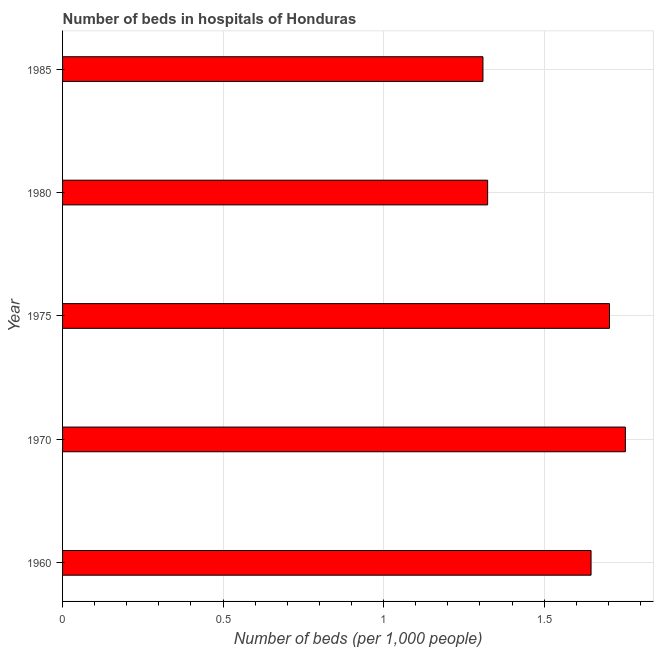Does the graph contain grids?
Offer a very short reply. Yes. What is the title of the graph?
Ensure brevity in your answer.  Number of beds in hospitals of Honduras. What is the label or title of the X-axis?
Give a very brief answer. Number of beds (per 1,0 people). What is the number of hospital beds in 1975?
Offer a very short reply. 1.7. Across all years, what is the maximum number of hospital beds?
Ensure brevity in your answer.  1.75. Across all years, what is the minimum number of hospital beds?
Offer a terse response. 1.31. In which year was the number of hospital beds maximum?
Offer a terse response. 1970. In which year was the number of hospital beds minimum?
Provide a short and direct response. 1985. What is the sum of the number of hospital beds?
Ensure brevity in your answer.  7.74. What is the difference between the number of hospital beds in 1975 and 1980?
Your answer should be very brief. 0.38. What is the average number of hospital beds per year?
Offer a very short reply. 1.55. What is the median number of hospital beds?
Provide a succinct answer. 1.65. Do a majority of the years between 1985 and 1970 (inclusive) have number of hospital beds greater than 1.2 %?
Make the answer very short. Yes. What is the ratio of the number of hospital beds in 1975 to that in 1985?
Make the answer very short. 1.3. Is the number of hospital beds in 1970 less than that in 1975?
Make the answer very short. No. Is the difference between the number of hospital beds in 1970 and 1975 greater than the difference between any two years?
Make the answer very short. No. What is the difference between the highest and the second highest number of hospital beds?
Your answer should be compact. 0.05. What is the difference between the highest and the lowest number of hospital beds?
Provide a short and direct response. 0.44. In how many years, is the number of hospital beds greater than the average number of hospital beds taken over all years?
Offer a terse response. 3. How many bars are there?
Provide a short and direct response. 5. What is the Number of beds (per 1,000 people) in 1960?
Provide a short and direct response. 1.65. What is the Number of beds (per 1,000 people) of 1970?
Offer a very short reply. 1.75. What is the Number of beds (per 1,000 people) of 1975?
Keep it short and to the point. 1.7. What is the Number of beds (per 1,000 people) in 1980?
Keep it short and to the point. 1.32. What is the Number of beds (per 1,000 people) of 1985?
Offer a terse response. 1.31. What is the difference between the Number of beds (per 1,000 people) in 1960 and 1970?
Make the answer very short. -0.11. What is the difference between the Number of beds (per 1,000 people) in 1960 and 1975?
Offer a very short reply. -0.06. What is the difference between the Number of beds (per 1,000 people) in 1960 and 1980?
Give a very brief answer. 0.32. What is the difference between the Number of beds (per 1,000 people) in 1960 and 1985?
Ensure brevity in your answer.  0.34. What is the difference between the Number of beds (per 1,000 people) in 1970 and 1975?
Ensure brevity in your answer.  0.05. What is the difference between the Number of beds (per 1,000 people) in 1970 and 1980?
Give a very brief answer. 0.43. What is the difference between the Number of beds (per 1,000 people) in 1970 and 1985?
Make the answer very short. 0.44. What is the difference between the Number of beds (per 1,000 people) in 1975 and 1980?
Keep it short and to the point. 0.38. What is the difference between the Number of beds (per 1,000 people) in 1975 and 1985?
Your answer should be very brief. 0.39. What is the difference between the Number of beds (per 1,000 people) in 1980 and 1985?
Ensure brevity in your answer.  0.01. What is the ratio of the Number of beds (per 1,000 people) in 1960 to that in 1970?
Provide a succinct answer. 0.94. What is the ratio of the Number of beds (per 1,000 people) in 1960 to that in 1975?
Keep it short and to the point. 0.97. What is the ratio of the Number of beds (per 1,000 people) in 1960 to that in 1980?
Offer a terse response. 1.24. What is the ratio of the Number of beds (per 1,000 people) in 1960 to that in 1985?
Provide a succinct answer. 1.26. What is the ratio of the Number of beds (per 1,000 people) in 1970 to that in 1975?
Give a very brief answer. 1.03. What is the ratio of the Number of beds (per 1,000 people) in 1970 to that in 1980?
Provide a short and direct response. 1.32. What is the ratio of the Number of beds (per 1,000 people) in 1970 to that in 1985?
Your answer should be compact. 1.34. What is the ratio of the Number of beds (per 1,000 people) in 1975 to that in 1980?
Your response must be concise. 1.29. What is the ratio of the Number of beds (per 1,000 people) in 1975 to that in 1985?
Provide a short and direct response. 1.3. 